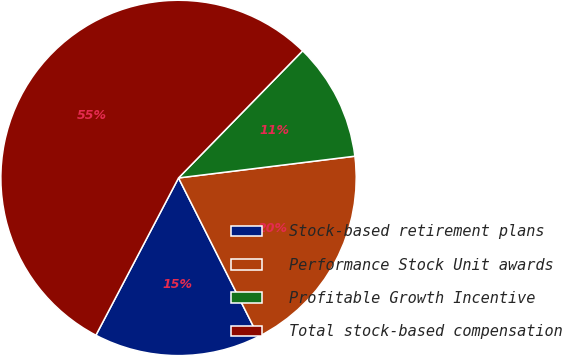Convert chart. <chart><loc_0><loc_0><loc_500><loc_500><pie_chart><fcel>Stock-based retirement plans<fcel>Performance Stock Unit awards<fcel>Profitable Growth Incentive<fcel>Total stock-based compensation<nl><fcel>15.13%<fcel>19.52%<fcel>10.74%<fcel>54.61%<nl></chart> 